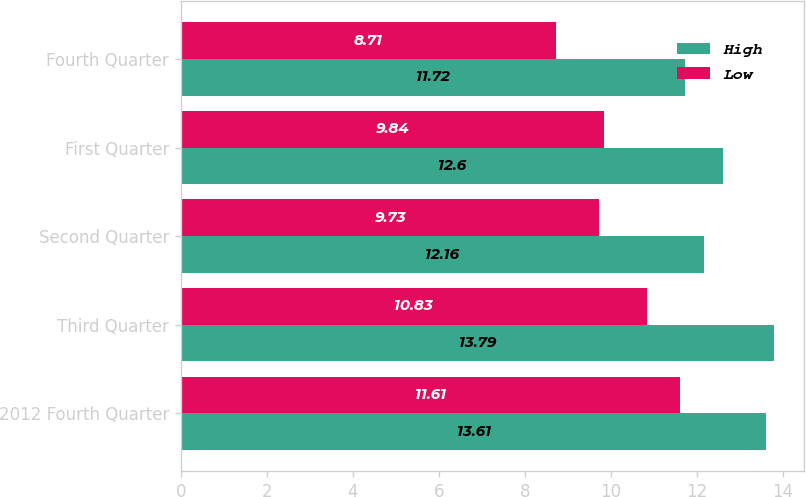<chart> <loc_0><loc_0><loc_500><loc_500><stacked_bar_chart><ecel><fcel>2012 Fourth Quarter<fcel>Third Quarter<fcel>Second Quarter<fcel>First Quarter<fcel>Fourth Quarter<nl><fcel>High<fcel>13.61<fcel>13.79<fcel>12.16<fcel>12.6<fcel>11.72<nl><fcel>Low<fcel>11.61<fcel>10.83<fcel>9.73<fcel>9.84<fcel>8.71<nl></chart> 